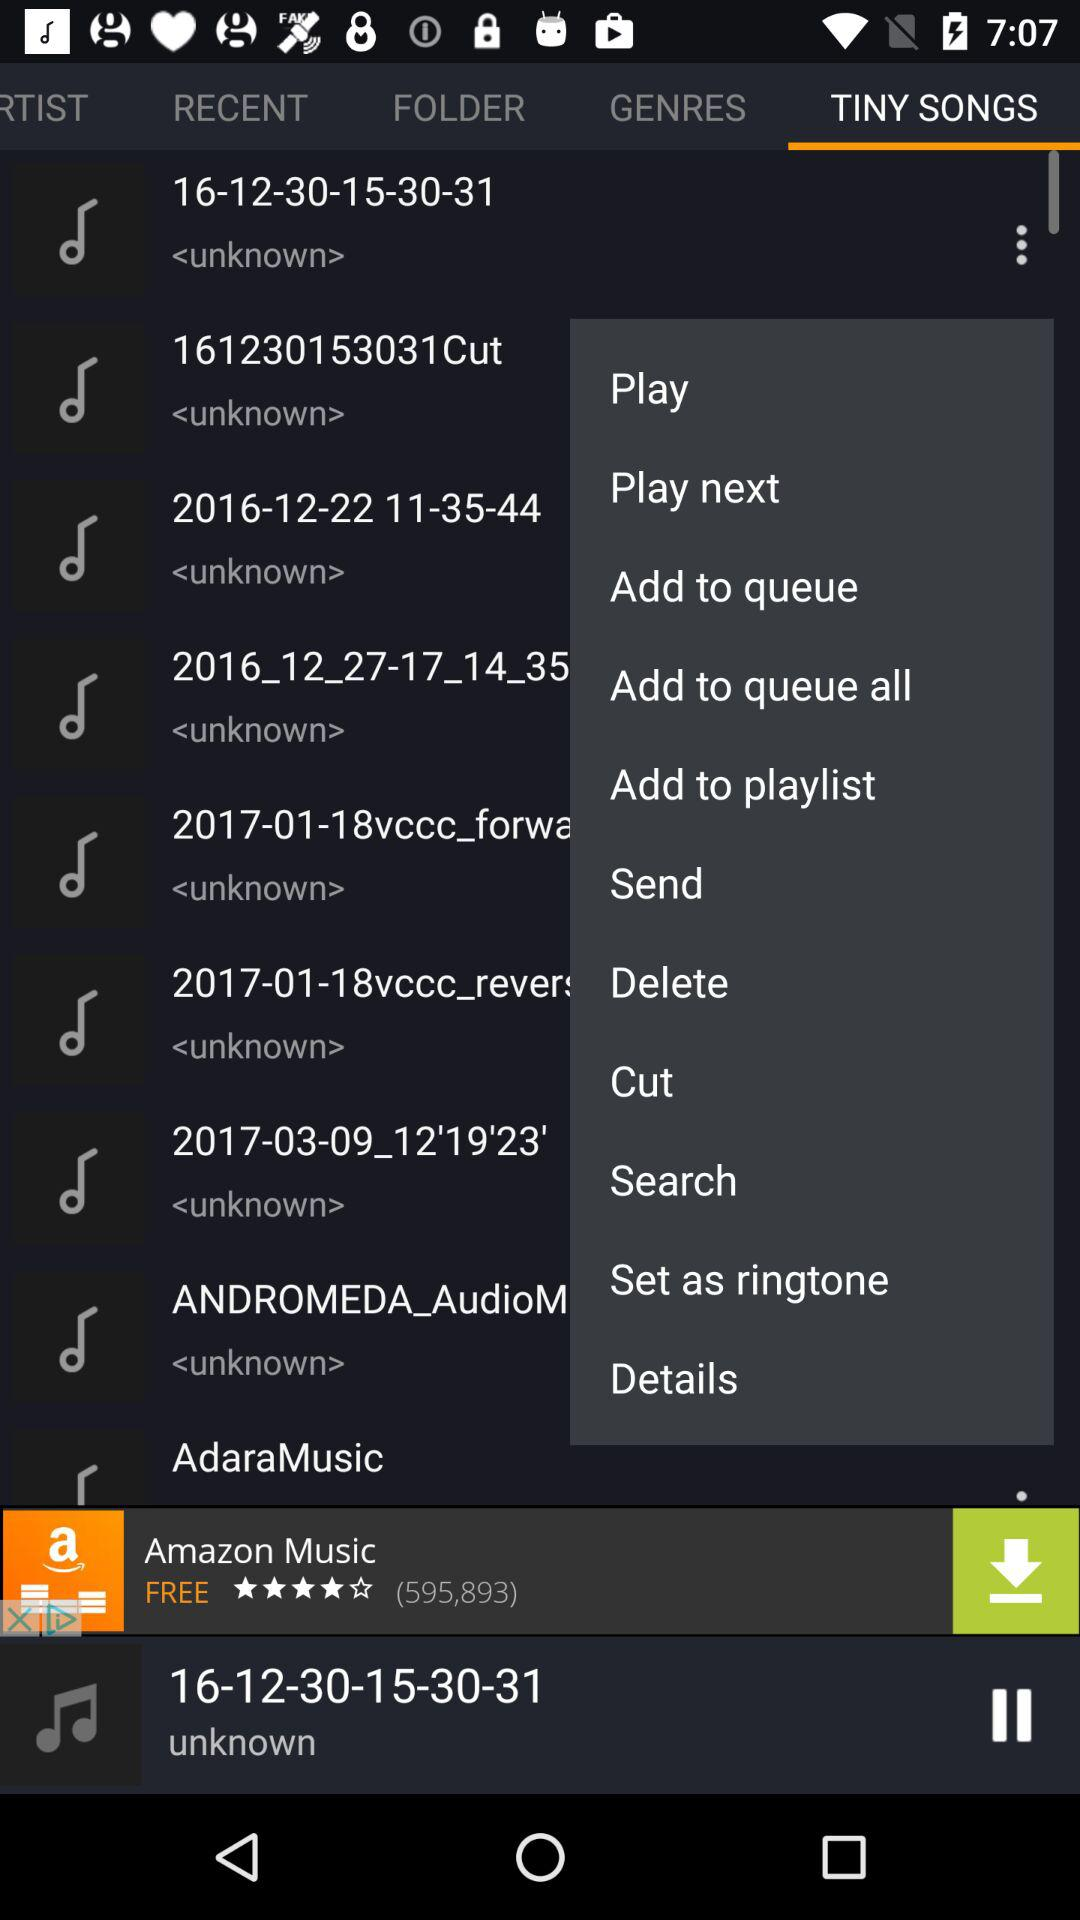How many items have the text "Cut" in them?
Answer the question using a single word or phrase. 1 